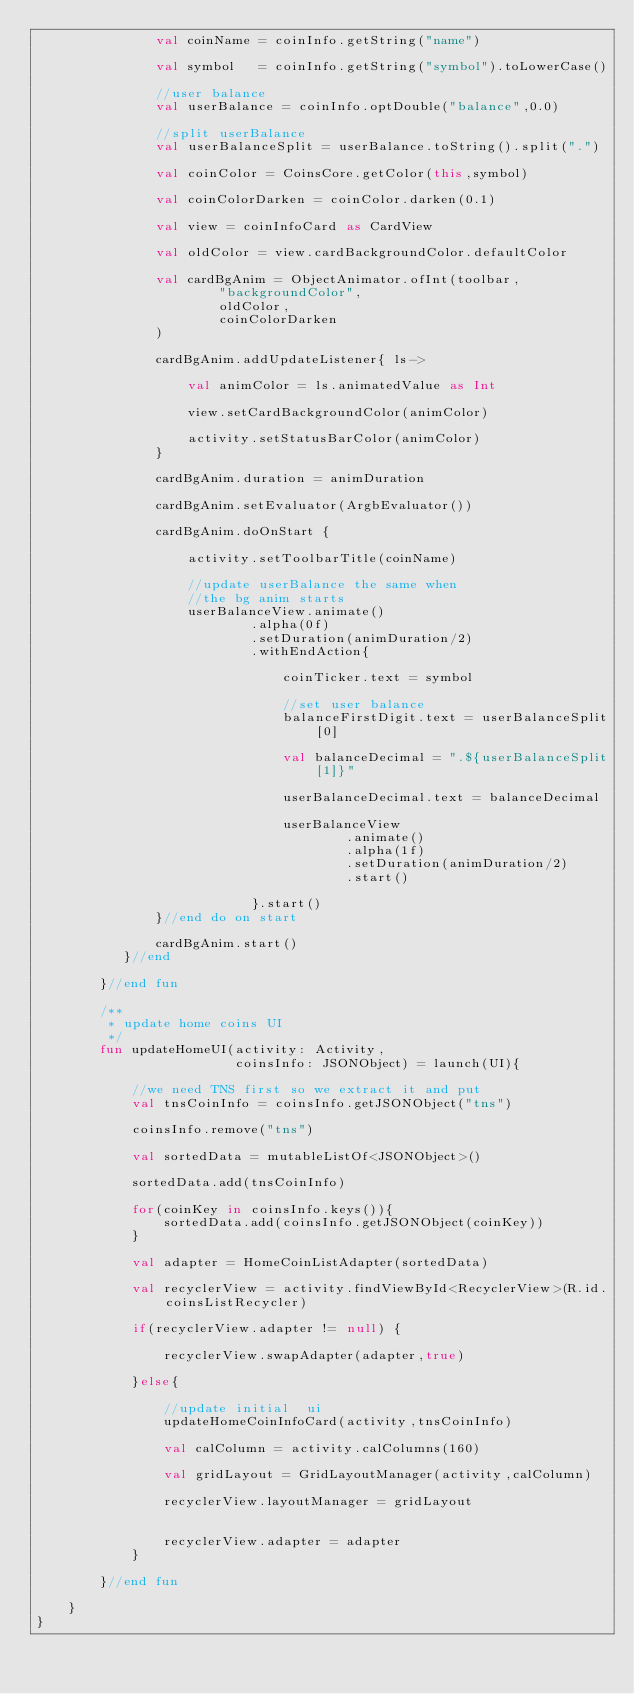Convert code to text. <code><loc_0><loc_0><loc_500><loc_500><_Kotlin_>               val coinName = coinInfo.getString("name")

               val symbol   = coinInfo.getString("symbol").toLowerCase()

               //user balance
               val userBalance = coinInfo.optDouble("balance",0.0)

               //split userBalance
               val userBalanceSplit = userBalance.toString().split(".")

               val coinColor = CoinsCore.getColor(this,symbol)

               val coinColorDarken = coinColor.darken(0.1)

               val view = coinInfoCard as CardView

               val oldColor = view.cardBackgroundColor.defaultColor

               val cardBgAnim = ObjectAnimator.ofInt(toolbar,
                       "backgroundColor",
                       oldColor,
                       coinColorDarken
               )

               cardBgAnim.addUpdateListener{ ls->

                   val animColor = ls.animatedValue as Int

                   view.setCardBackgroundColor(animColor)

                   activity.setStatusBarColor(animColor)
               }

               cardBgAnim.duration = animDuration

               cardBgAnim.setEvaluator(ArgbEvaluator())

               cardBgAnim.doOnStart {

                   activity.setToolbarTitle(coinName)

                   //update userBalance the same when
                   //the bg anim starts
                   userBalanceView.animate()
                           .alpha(0f)
                           .setDuration(animDuration/2)
                           .withEndAction{

                               coinTicker.text = symbol

                               //set user balance
                               balanceFirstDigit.text = userBalanceSplit[0]

                               val balanceDecimal = ".${userBalanceSplit[1]}"

                               userBalanceDecimal.text = balanceDecimal

                               userBalanceView
                                       .animate()
                                       .alpha(1f)
                                       .setDuration(animDuration/2)
                                       .start()

                           }.start()
               }//end do on start

               cardBgAnim.start()
           }//end

        }//end fun

        /**
         * update home coins UI
         */
        fun updateHomeUI(activity: Activity,
                         coinsInfo: JSONObject) = launch(UI){

            //we need TNS first so we extract it and put
            val tnsCoinInfo = coinsInfo.getJSONObject("tns")

            coinsInfo.remove("tns")

            val sortedData = mutableListOf<JSONObject>()

            sortedData.add(tnsCoinInfo)

            for(coinKey in coinsInfo.keys()){
                sortedData.add(coinsInfo.getJSONObject(coinKey))
            }

            val adapter = HomeCoinListAdapter(sortedData)

            val recyclerView = activity.findViewById<RecyclerView>(R.id.coinsListRecycler)

            if(recyclerView.adapter != null) {

                recyclerView.swapAdapter(adapter,true)

            }else{

                //update initial  ui
                updateHomeCoinInfoCard(activity,tnsCoinInfo)

                val calColumn = activity.calColumns(160)

                val gridLayout = GridLayoutManager(activity,calColumn)

                recyclerView.layoutManager = gridLayout


                recyclerView.adapter = adapter
            }

        }//end fun

    }
}

</code> 